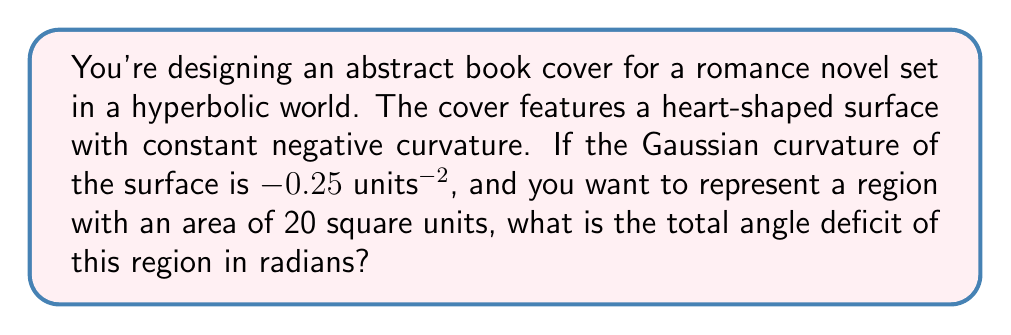Can you answer this question? To solve this problem, we'll use the Gauss-Bonnet theorem for hyperbolic surfaces. The steps are as follows:

1) Recall the Gauss-Bonnet theorem for a region R on a surface:

   $$\int\int_R K dA + \int_{\partial R} k_g ds + \sum_i \theta_i = 2\pi\chi(R)$$

   Where:
   - K is the Gaussian curvature
   - dA is the area element
   - k_g is the geodesic curvature of the boundary
   - θ_i are the exterior angles at the vertices
   - χ(R) is the Euler characteristic of the region

2) For a simply connected region on a hyperbolic surface, χ(R) = 1.

3) The left side of the equation represents the total angle deficit. Let's call this Δ.

4) For a surface with constant curvature K, the first term simplifies to K * A, where A is the area of the region.

5) Substituting the given values:

   $$\Delta = 2\pi - KA = 2\pi - (-0.25 * 20)$$

6) Simplify:

   $$\Delta = 2\pi + 5 = 2\pi + \frac{5\pi}{\pi} = \frac{7\pi}{\pi}$$

Thus, the total angle deficit is 7π radians.
Answer: 7π radians 